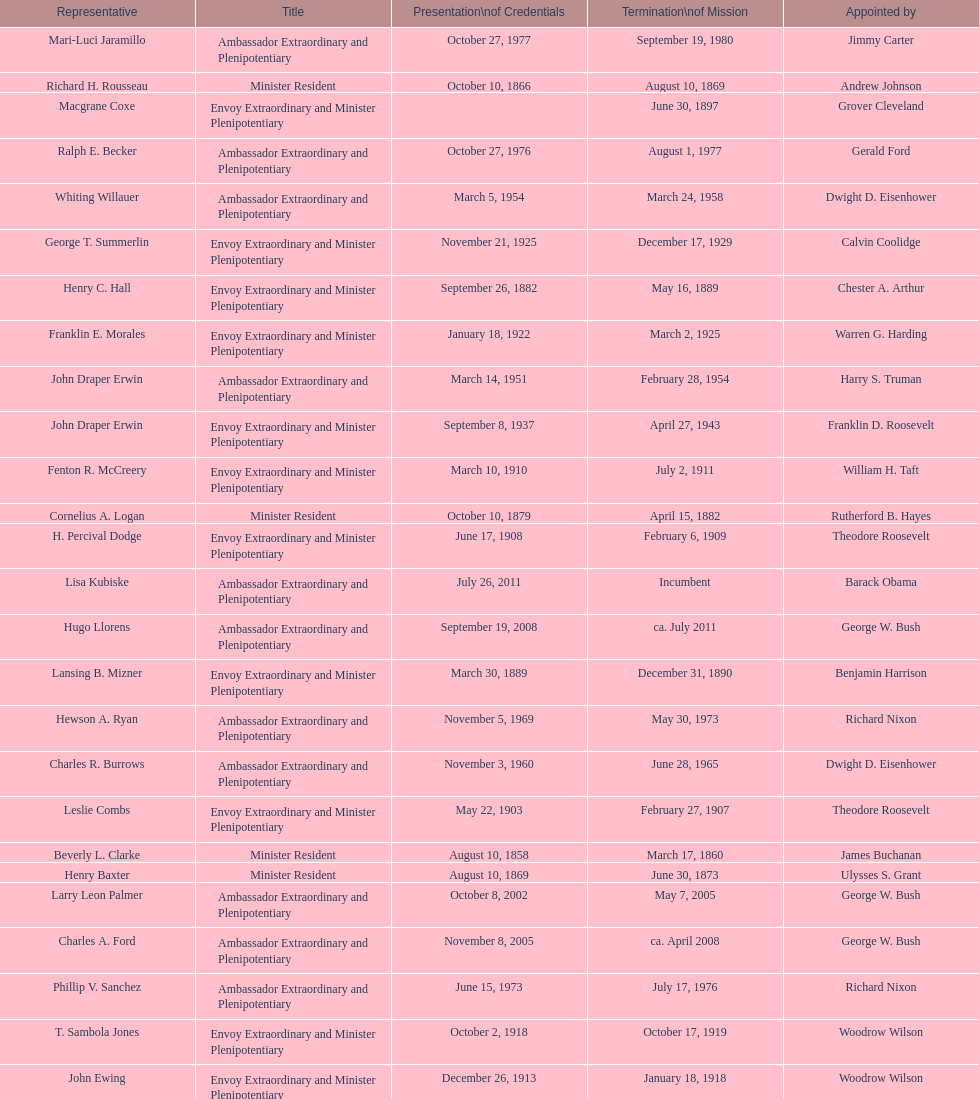Would you be able to parse every entry in this table? {'header': ['Representative', 'Title', 'Presentation\\nof Credentials', 'Termination\\nof Mission', 'Appointed by'], 'rows': [['Mari-Luci Jaramillo', 'Ambassador Extraordinary and Plenipotentiary', 'October 27, 1977', 'September 19, 1980', 'Jimmy Carter'], ['Richard H. Rousseau', 'Minister Resident', 'October 10, 1866', 'August 10, 1869', 'Andrew Johnson'], ['Macgrane Coxe', 'Envoy Extraordinary and Minister Plenipotentiary', '', 'June 30, 1897', 'Grover Cleveland'], ['Ralph E. Becker', 'Ambassador Extraordinary and Plenipotentiary', 'October 27, 1976', 'August 1, 1977', 'Gerald Ford'], ['Whiting Willauer', 'Ambassador Extraordinary and Plenipotentiary', 'March 5, 1954', 'March 24, 1958', 'Dwight D. Eisenhower'], ['George T. Summerlin', 'Envoy Extraordinary and Minister Plenipotentiary', 'November 21, 1925', 'December 17, 1929', 'Calvin Coolidge'], ['Henry C. Hall', 'Envoy Extraordinary and Minister Plenipotentiary', 'September 26, 1882', 'May 16, 1889', 'Chester A. Arthur'], ['Franklin E. Morales', 'Envoy Extraordinary and Minister Plenipotentiary', 'January 18, 1922', 'March 2, 1925', 'Warren G. Harding'], ['John Draper Erwin', 'Ambassador Extraordinary and Plenipotentiary', 'March 14, 1951', 'February 28, 1954', 'Harry S. Truman'], ['John Draper Erwin', 'Envoy Extraordinary and Minister Plenipotentiary', 'September 8, 1937', 'April 27, 1943', 'Franklin D. Roosevelt'], ['Fenton R. McCreery', 'Envoy Extraordinary and Minister Plenipotentiary', 'March 10, 1910', 'July 2, 1911', 'William H. Taft'], ['Cornelius A. Logan', 'Minister Resident', 'October 10, 1879', 'April 15, 1882', 'Rutherford B. Hayes'], ['H. Percival Dodge', 'Envoy Extraordinary and Minister Plenipotentiary', 'June 17, 1908', 'February 6, 1909', 'Theodore Roosevelt'], ['Lisa Kubiske', 'Ambassador Extraordinary and Plenipotentiary', 'July 26, 2011', 'Incumbent', 'Barack Obama'], ['Hugo Llorens', 'Ambassador Extraordinary and Plenipotentiary', 'September 19, 2008', 'ca. July 2011', 'George W. Bush'], ['Lansing B. Mizner', 'Envoy Extraordinary and Minister Plenipotentiary', 'March 30, 1889', 'December 31, 1890', 'Benjamin Harrison'], ['Hewson A. Ryan', 'Ambassador Extraordinary and Plenipotentiary', 'November 5, 1969', 'May 30, 1973', 'Richard Nixon'], ['Charles R. Burrows', 'Ambassador Extraordinary and Plenipotentiary', 'November 3, 1960', 'June 28, 1965', 'Dwight D. Eisenhower'], ['Leslie Combs', 'Envoy Extraordinary and Minister Plenipotentiary', 'May 22, 1903', 'February 27, 1907', 'Theodore Roosevelt'], ['Beverly L. Clarke', 'Minister Resident', 'August 10, 1858', 'March 17, 1860', 'James Buchanan'], ['Henry Baxter', 'Minister Resident', 'August 10, 1869', 'June 30, 1873', 'Ulysses S. Grant'], ['Larry Leon Palmer', 'Ambassador Extraordinary and Plenipotentiary', 'October 8, 2002', 'May 7, 2005', 'George W. Bush'], ['Charles A. Ford', 'Ambassador Extraordinary and Plenipotentiary', 'November 8, 2005', 'ca. April 2008', 'George W. Bush'], ['Phillip V. Sanchez', 'Ambassador Extraordinary and Plenipotentiary', 'June 15, 1973', 'July 17, 1976', 'Richard Nixon'], ['T. Sambola Jones', 'Envoy Extraordinary and Minister Plenipotentiary', 'October 2, 1918', 'October 17, 1919', 'Woodrow Wilson'], ['John Ewing', 'Envoy Extraordinary and Minister Plenipotentiary', 'December 26, 1913', 'January 18, 1918', 'Woodrow Wilson'], ['Jack R. Binns', 'Ambassador Extraordinary and Plenipotentiary', 'October 10, 1980', 'October 31, 1981', 'Jimmy Carter'], ['Philip Marshall Brown', 'Envoy Extraordinary and Minister Plenipotentiary', 'February 21, 1909', 'February 26, 1910', 'Theodore Roosevelt'], ['Pierce M. B. Young', 'Envoy Extraordinary and Minister Plenipotentiary', 'November 12, 1893', 'May 23, 1896', 'Grover Cleveland'], ['Romualdo Pacheco', 'Envoy Extraordinary and Minister Plenipotentiary', 'April 17, 1891', 'June 12, 1893', 'Benjamin Harrison'], ['Joseph J. Jova', 'Ambassador Extraordinary and Plenipotentiary', 'July 12, 1965', 'June 21, 1969', 'Lyndon B. Johnson'], ['Charles Dunning White', 'Envoy Extraordinary and Minister Plenipotentiary', 'September 9, 1911', 'November 4, 1913', 'William H. Taft'], ['W. Godfrey Hunter', 'Envoy Extraordinary and Minister Plenipotentiary', 'January 19, 1899', 'February 2, 1903', 'William McKinley'], ['Henry C. Hall', 'Minister Resident', 'April 21, 1882', 'September 26, 1882', 'Chester A. Arthur'], ['Frank Almaguer', 'Ambassador Extraordinary and Plenipotentiary', 'August 25, 1999', 'September 5, 2002', 'Bill Clinton'], ['Paul C. Daniels', 'Ambassador Extraordinary and Plenipotentiary', 'June 23, 1947', 'October 30, 1947', 'Harry S. Truman'], ['Cresencio S. Arcos, Jr.', 'Ambassador Extraordinary and Plenipotentiary', 'January 29, 1990', 'July 1, 1993', 'George H. W. Bush'], ['John Arthur Ferch', 'Ambassador Extraordinary and Plenipotentiary', 'August 22, 1985', 'July 9, 1986', 'Ronald Reagan'], ['John Draper Erwin', 'Ambassador Extraordinary and Plenipotentiary', 'April 27, 1943', 'April 16, 1947', 'Franklin D. Roosevelt'], ['Herbert S. Bursley', 'Ambassador Extraordinary and Plenipotentiary', 'May 15, 1948', 'December 12, 1950', 'Harry S. Truman'], ['Thomas H. Clay', 'Minister Resident', 'April 5, 1864', 'August 10, 1866', 'Abraham Lincoln'], ['Everett Ellis Briggs', 'Ambassador Extraordinary and Plenipotentiary', 'November 4, 1986', 'June 15, 1989', 'Ronald Reagan'], ['James R. Partridge', 'Minister Resident', 'April 25, 1862', 'November 14, 1862', 'Abraham Lincoln'], ['James F. Creagan', 'Ambassador Extraordinary and Plenipotentiary', 'August 29, 1996', 'July 20, 1999', 'Bill Clinton'], ['George Williamson', 'Minister Resident', 'February 19, 1874', 'January 31, 1879', 'Ulysses S. Grant'], ['Joseph W. J. Lee', 'Envoy Extraordinary and Minister Plenipotentiary', '', 'July 1, 1907', 'Theodore Roosevelt'], ['Robert Newbegin', 'Ambassador Extraordinary and Plenipotentiary', 'April 30, 1958', 'August 3, 1960', 'Dwight D. Eisenhower'], ['John D. Negroponte', 'Ambassador Extraordinary and Plenipotentiary', 'November 11, 1981', 'May 30, 1985', 'Ronald Reagan'], ['Leo J. Keena', 'Envoy Extraordinary and Minister Plenipotentiary', 'July 19, 1935', 'May 1, 1937', 'Franklin D. Roosevelt'], ['Julius G. Lay', 'Envoy Extraordinary and Minister Plenipotentiary', 'May 31, 1930', 'March 17, 1935', 'Herbert Hoover'], ['Solon Borland', 'Envoy Extraordinary and Minister Plenipotentiary', '', 'April 17, 1854', 'Franklin Pierce'], ['William Thornton Pryce', 'Ambassador Extraordinary and Plenipotentiary', 'July 21, 1993', 'August 15, 1996', 'Bill Clinton']]} Which ambassador to honduras held the position for the longest duration? Henry C. Hall. 